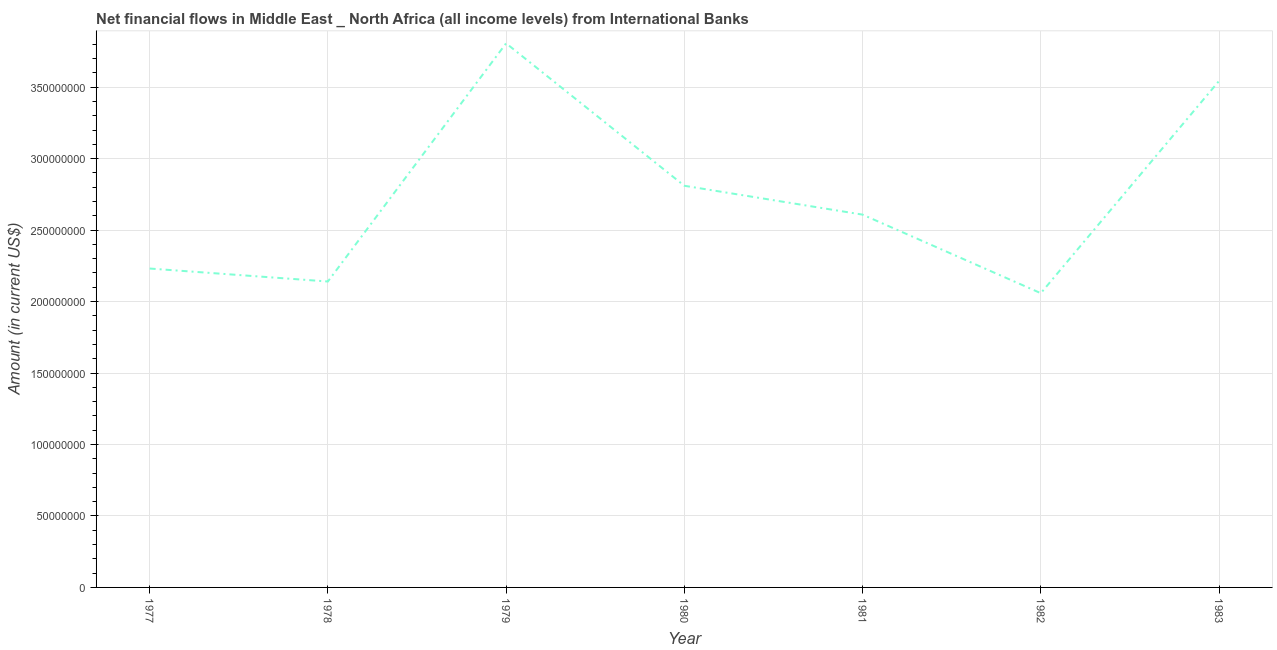What is the net financial flows from ibrd in 1978?
Your answer should be compact. 2.14e+08. Across all years, what is the maximum net financial flows from ibrd?
Offer a very short reply. 3.81e+08. Across all years, what is the minimum net financial flows from ibrd?
Provide a short and direct response. 2.06e+08. In which year was the net financial flows from ibrd maximum?
Offer a terse response. 1979. What is the sum of the net financial flows from ibrd?
Provide a succinct answer. 1.92e+09. What is the difference between the net financial flows from ibrd in 1980 and 1982?
Give a very brief answer. 7.52e+07. What is the average net financial flows from ibrd per year?
Give a very brief answer. 2.74e+08. What is the median net financial flows from ibrd?
Your answer should be compact. 2.61e+08. In how many years, is the net financial flows from ibrd greater than 110000000 US$?
Give a very brief answer. 7. Do a majority of the years between 1979 and 1982 (inclusive) have net financial flows from ibrd greater than 300000000 US$?
Give a very brief answer. No. What is the ratio of the net financial flows from ibrd in 1982 to that in 1983?
Your answer should be compact. 0.58. Is the net financial flows from ibrd in 1980 less than that in 1981?
Make the answer very short. No. Is the difference between the net financial flows from ibrd in 1977 and 1979 greater than the difference between any two years?
Provide a succinct answer. No. What is the difference between the highest and the second highest net financial flows from ibrd?
Ensure brevity in your answer.  2.63e+07. Is the sum of the net financial flows from ibrd in 1979 and 1981 greater than the maximum net financial flows from ibrd across all years?
Provide a short and direct response. Yes. What is the difference between the highest and the lowest net financial flows from ibrd?
Offer a very short reply. 1.75e+08. In how many years, is the net financial flows from ibrd greater than the average net financial flows from ibrd taken over all years?
Your answer should be very brief. 3. Does the graph contain grids?
Ensure brevity in your answer.  Yes. What is the title of the graph?
Keep it short and to the point. Net financial flows in Middle East _ North Africa (all income levels) from International Banks. What is the label or title of the X-axis?
Provide a succinct answer. Year. What is the Amount (in current US$) in 1977?
Keep it short and to the point. 2.23e+08. What is the Amount (in current US$) of 1978?
Provide a short and direct response. 2.14e+08. What is the Amount (in current US$) of 1979?
Make the answer very short. 3.81e+08. What is the Amount (in current US$) in 1980?
Offer a terse response. 2.81e+08. What is the Amount (in current US$) in 1981?
Give a very brief answer. 2.61e+08. What is the Amount (in current US$) in 1982?
Provide a short and direct response. 2.06e+08. What is the Amount (in current US$) in 1983?
Your response must be concise. 3.54e+08. What is the difference between the Amount (in current US$) in 1977 and 1978?
Provide a succinct answer. 9.08e+06. What is the difference between the Amount (in current US$) in 1977 and 1979?
Give a very brief answer. -1.58e+08. What is the difference between the Amount (in current US$) in 1977 and 1980?
Make the answer very short. -5.79e+07. What is the difference between the Amount (in current US$) in 1977 and 1981?
Your answer should be compact. -3.77e+07. What is the difference between the Amount (in current US$) in 1977 and 1982?
Provide a succinct answer. 1.73e+07. What is the difference between the Amount (in current US$) in 1977 and 1983?
Your answer should be compact. -1.31e+08. What is the difference between the Amount (in current US$) in 1978 and 1979?
Offer a terse response. -1.67e+08. What is the difference between the Amount (in current US$) in 1978 and 1980?
Keep it short and to the point. -6.70e+07. What is the difference between the Amount (in current US$) in 1978 and 1981?
Give a very brief answer. -4.68e+07. What is the difference between the Amount (in current US$) in 1978 and 1982?
Offer a very short reply. 8.17e+06. What is the difference between the Amount (in current US$) in 1978 and 1983?
Offer a terse response. -1.40e+08. What is the difference between the Amount (in current US$) in 1979 and 1980?
Keep it short and to the point. 9.97e+07. What is the difference between the Amount (in current US$) in 1979 and 1981?
Your answer should be very brief. 1.20e+08. What is the difference between the Amount (in current US$) in 1979 and 1982?
Your response must be concise. 1.75e+08. What is the difference between the Amount (in current US$) in 1979 and 1983?
Offer a terse response. 2.63e+07. What is the difference between the Amount (in current US$) in 1980 and 1981?
Ensure brevity in your answer.  2.02e+07. What is the difference between the Amount (in current US$) in 1980 and 1982?
Your answer should be very brief. 7.52e+07. What is the difference between the Amount (in current US$) in 1980 and 1983?
Keep it short and to the point. -7.33e+07. What is the difference between the Amount (in current US$) in 1981 and 1982?
Your response must be concise. 5.50e+07. What is the difference between the Amount (in current US$) in 1981 and 1983?
Offer a very short reply. -9.35e+07. What is the difference between the Amount (in current US$) in 1982 and 1983?
Your response must be concise. -1.48e+08. What is the ratio of the Amount (in current US$) in 1977 to that in 1978?
Offer a very short reply. 1.04. What is the ratio of the Amount (in current US$) in 1977 to that in 1979?
Offer a very short reply. 0.59. What is the ratio of the Amount (in current US$) in 1977 to that in 1980?
Your answer should be compact. 0.79. What is the ratio of the Amount (in current US$) in 1977 to that in 1981?
Make the answer very short. 0.85. What is the ratio of the Amount (in current US$) in 1977 to that in 1982?
Offer a very short reply. 1.08. What is the ratio of the Amount (in current US$) in 1977 to that in 1983?
Your answer should be compact. 0.63. What is the ratio of the Amount (in current US$) in 1978 to that in 1979?
Provide a short and direct response. 0.56. What is the ratio of the Amount (in current US$) in 1978 to that in 1980?
Offer a very short reply. 0.76. What is the ratio of the Amount (in current US$) in 1978 to that in 1981?
Offer a terse response. 0.82. What is the ratio of the Amount (in current US$) in 1978 to that in 1983?
Your response must be concise. 0.6. What is the ratio of the Amount (in current US$) in 1979 to that in 1980?
Offer a very short reply. 1.35. What is the ratio of the Amount (in current US$) in 1979 to that in 1981?
Your response must be concise. 1.46. What is the ratio of the Amount (in current US$) in 1979 to that in 1982?
Your response must be concise. 1.85. What is the ratio of the Amount (in current US$) in 1979 to that in 1983?
Ensure brevity in your answer.  1.07. What is the ratio of the Amount (in current US$) in 1980 to that in 1981?
Provide a succinct answer. 1.08. What is the ratio of the Amount (in current US$) in 1980 to that in 1982?
Offer a terse response. 1.36. What is the ratio of the Amount (in current US$) in 1980 to that in 1983?
Provide a short and direct response. 0.79. What is the ratio of the Amount (in current US$) in 1981 to that in 1982?
Your answer should be compact. 1.27. What is the ratio of the Amount (in current US$) in 1981 to that in 1983?
Provide a succinct answer. 0.74. What is the ratio of the Amount (in current US$) in 1982 to that in 1983?
Offer a very short reply. 0.58. 